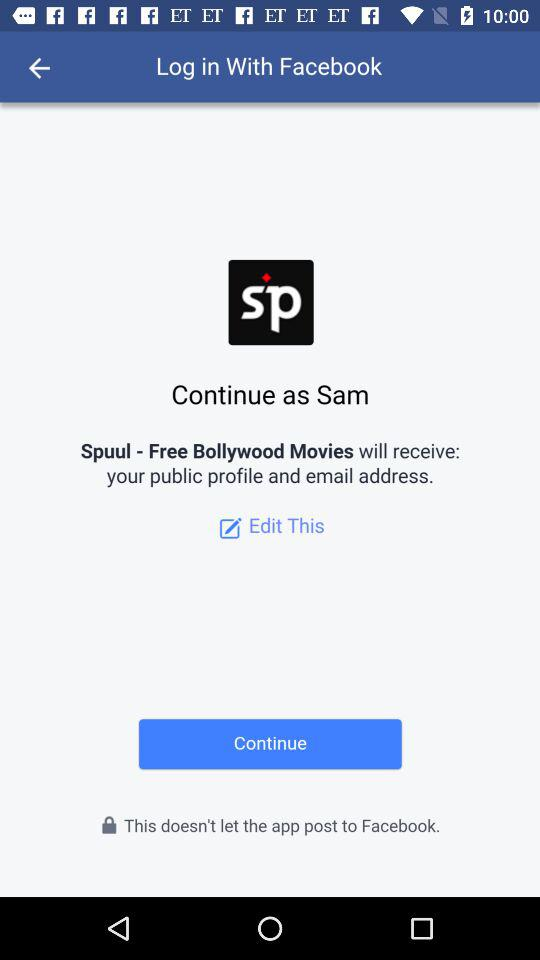What application is asking for permission? The application asking for permission is "Spuul - Free Bollywood Movies". 